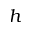<formula> <loc_0><loc_0><loc_500><loc_500>h</formula> 